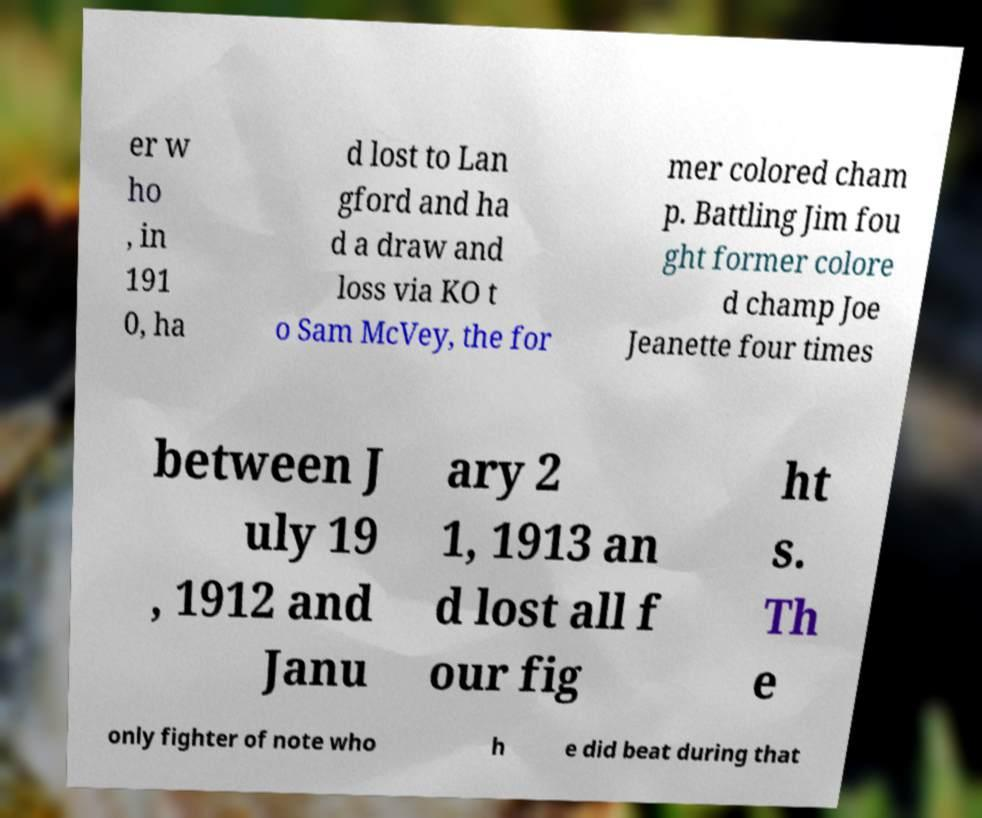Can you accurately transcribe the text from the provided image for me? er w ho , in 191 0, ha d lost to Lan gford and ha d a draw and loss via KO t o Sam McVey, the for mer colored cham p. Battling Jim fou ght former colore d champ Joe Jeanette four times between J uly 19 , 1912 and Janu ary 2 1, 1913 an d lost all f our fig ht s. Th e only fighter of note who h e did beat during that 